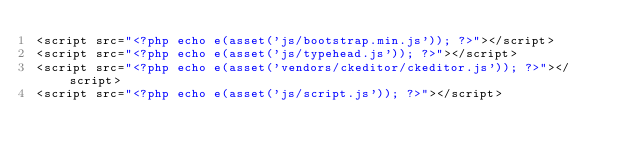<code> <loc_0><loc_0><loc_500><loc_500><_PHP_><script src="<?php echo e(asset('js/bootstrap.min.js')); ?>"></script>
<script src="<?php echo e(asset('js/typehead.js')); ?>"></script>
<script src="<?php echo e(asset('vendors/ckeditor/ckeditor.js')); ?>"></script>
<script src="<?php echo e(asset('js/script.js')); ?>"></script>
</code> 